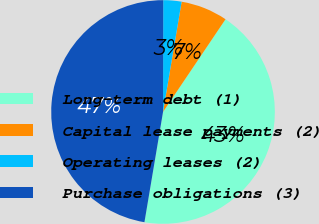Convert chart to OTSL. <chart><loc_0><loc_0><loc_500><loc_500><pie_chart><fcel>Long-term debt (1)<fcel>Capital lease payments (2)<fcel>Operating leases (2)<fcel>Purchase obligations (3)<nl><fcel>43.22%<fcel>6.78%<fcel>2.63%<fcel>47.37%<nl></chart> 